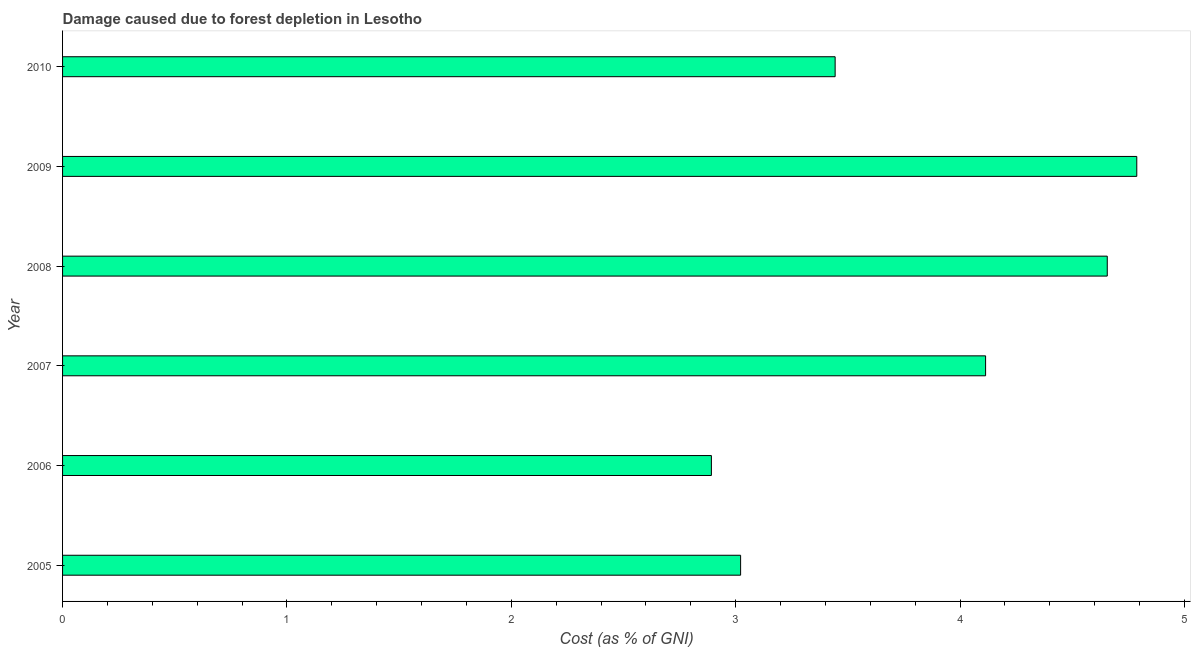Does the graph contain any zero values?
Offer a terse response. No. What is the title of the graph?
Provide a short and direct response. Damage caused due to forest depletion in Lesotho. What is the label or title of the X-axis?
Your response must be concise. Cost (as % of GNI). What is the label or title of the Y-axis?
Your answer should be very brief. Year. What is the damage caused due to forest depletion in 2005?
Make the answer very short. 3.02. Across all years, what is the maximum damage caused due to forest depletion?
Offer a very short reply. 4.79. Across all years, what is the minimum damage caused due to forest depletion?
Offer a very short reply. 2.89. In which year was the damage caused due to forest depletion minimum?
Ensure brevity in your answer.  2006. What is the sum of the damage caused due to forest depletion?
Give a very brief answer. 22.91. What is the difference between the damage caused due to forest depletion in 2007 and 2009?
Give a very brief answer. -0.67. What is the average damage caused due to forest depletion per year?
Your answer should be compact. 3.82. What is the median damage caused due to forest depletion?
Give a very brief answer. 3.78. What is the ratio of the damage caused due to forest depletion in 2005 to that in 2007?
Give a very brief answer. 0.73. Is the difference between the damage caused due to forest depletion in 2005 and 2007 greater than the difference between any two years?
Offer a terse response. No. What is the difference between the highest and the second highest damage caused due to forest depletion?
Keep it short and to the point. 0.13. What is the difference between the highest and the lowest damage caused due to forest depletion?
Your answer should be compact. 1.9. In how many years, is the damage caused due to forest depletion greater than the average damage caused due to forest depletion taken over all years?
Offer a terse response. 3. How many years are there in the graph?
Your answer should be compact. 6. What is the difference between two consecutive major ticks on the X-axis?
Your response must be concise. 1. Are the values on the major ticks of X-axis written in scientific E-notation?
Ensure brevity in your answer.  No. What is the Cost (as % of GNI) of 2005?
Give a very brief answer. 3.02. What is the Cost (as % of GNI) of 2006?
Provide a succinct answer. 2.89. What is the Cost (as % of GNI) of 2007?
Make the answer very short. 4.11. What is the Cost (as % of GNI) of 2008?
Ensure brevity in your answer.  4.66. What is the Cost (as % of GNI) of 2009?
Provide a short and direct response. 4.79. What is the Cost (as % of GNI) of 2010?
Offer a very short reply. 3.44. What is the difference between the Cost (as % of GNI) in 2005 and 2006?
Your answer should be very brief. 0.13. What is the difference between the Cost (as % of GNI) in 2005 and 2007?
Your response must be concise. -1.09. What is the difference between the Cost (as % of GNI) in 2005 and 2008?
Offer a terse response. -1.63. What is the difference between the Cost (as % of GNI) in 2005 and 2009?
Your answer should be very brief. -1.77. What is the difference between the Cost (as % of GNI) in 2005 and 2010?
Your answer should be very brief. -0.42. What is the difference between the Cost (as % of GNI) in 2006 and 2007?
Ensure brevity in your answer.  -1.22. What is the difference between the Cost (as % of GNI) in 2006 and 2008?
Keep it short and to the point. -1.76. What is the difference between the Cost (as % of GNI) in 2006 and 2009?
Make the answer very short. -1.9. What is the difference between the Cost (as % of GNI) in 2006 and 2010?
Keep it short and to the point. -0.55. What is the difference between the Cost (as % of GNI) in 2007 and 2008?
Your answer should be compact. -0.54. What is the difference between the Cost (as % of GNI) in 2007 and 2009?
Your answer should be compact. -0.67. What is the difference between the Cost (as % of GNI) in 2007 and 2010?
Ensure brevity in your answer.  0.67. What is the difference between the Cost (as % of GNI) in 2008 and 2009?
Offer a terse response. -0.13. What is the difference between the Cost (as % of GNI) in 2008 and 2010?
Ensure brevity in your answer.  1.21. What is the difference between the Cost (as % of GNI) in 2009 and 2010?
Make the answer very short. 1.34. What is the ratio of the Cost (as % of GNI) in 2005 to that in 2006?
Provide a short and direct response. 1.04. What is the ratio of the Cost (as % of GNI) in 2005 to that in 2007?
Offer a very short reply. 0.73. What is the ratio of the Cost (as % of GNI) in 2005 to that in 2008?
Provide a short and direct response. 0.65. What is the ratio of the Cost (as % of GNI) in 2005 to that in 2009?
Offer a terse response. 0.63. What is the ratio of the Cost (as % of GNI) in 2005 to that in 2010?
Offer a terse response. 0.88. What is the ratio of the Cost (as % of GNI) in 2006 to that in 2007?
Keep it short and to the point. 0.7. What is the ratio of the Cost (as % of GNI) in 2006 to that in 2008?
Provide a succinct answer. 0.62. What is the ratio of the Cost (as % of GNI) in 2006 to that in 2009?
Make the answer very short. 0.6. What is the ratio of the Cost (as % of GNI) in 2006 to that in 2010?
Your response must be concise. 0.84. What is the ratio of the Cost (as % of GNI) in 2007 to that in 2008?
Offer a very short reply. 0.88. What is the ratio of the Cost (as % of GNI) in 2007 to that in 2009?
Offer a terse response. 0.86. What is the ratio of the Cost (as % of GNI) in 2007 to that in 2010?
Offer a terse response. 1.2. What is the ratio of the Cost (as % of GNI) in 2008 to that in 2010?
Your answer should be compact. 1.35. What is the ratio of the Cost (as % of GNI) in 2009 to that in 2010?
Provide a short and direct response. 1.39. 